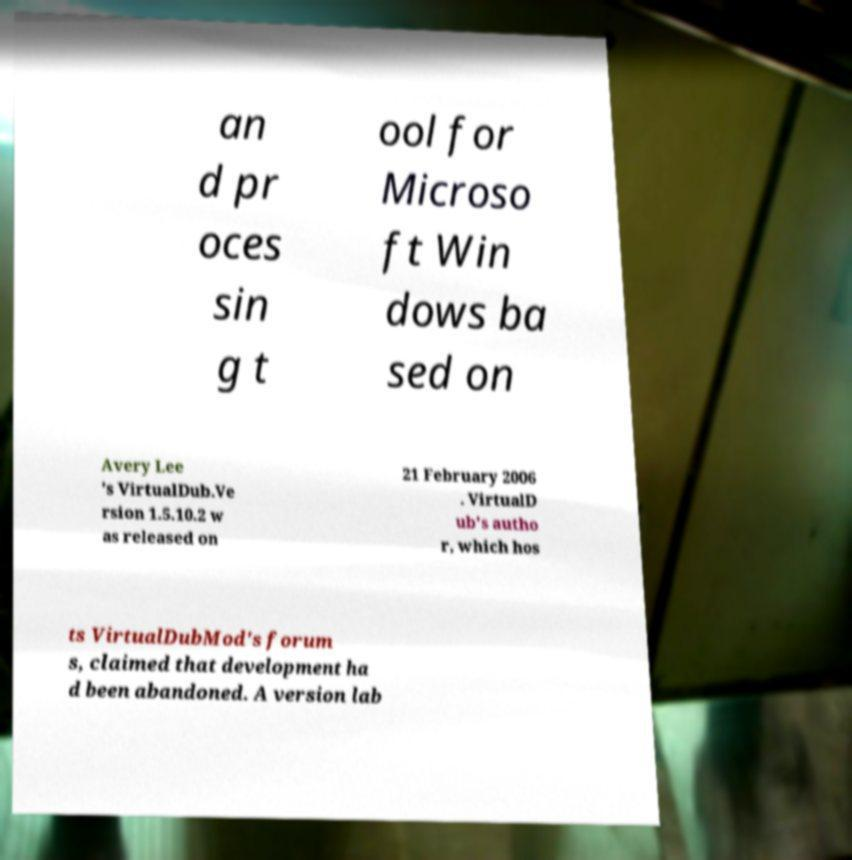Can you accurately transcribe the text from the provided image for me? an d pr oces sin g t ool for Microso ft Win dows ba sed on Avery Lee 's VirtualDub.Ve rsion 1.5.10.2 w as released on 21 February 2006 . VirtualD ub's autho r, which hos ts VirtualDubMod's forum s, claimed that development ha d been abandoned. A version lab 